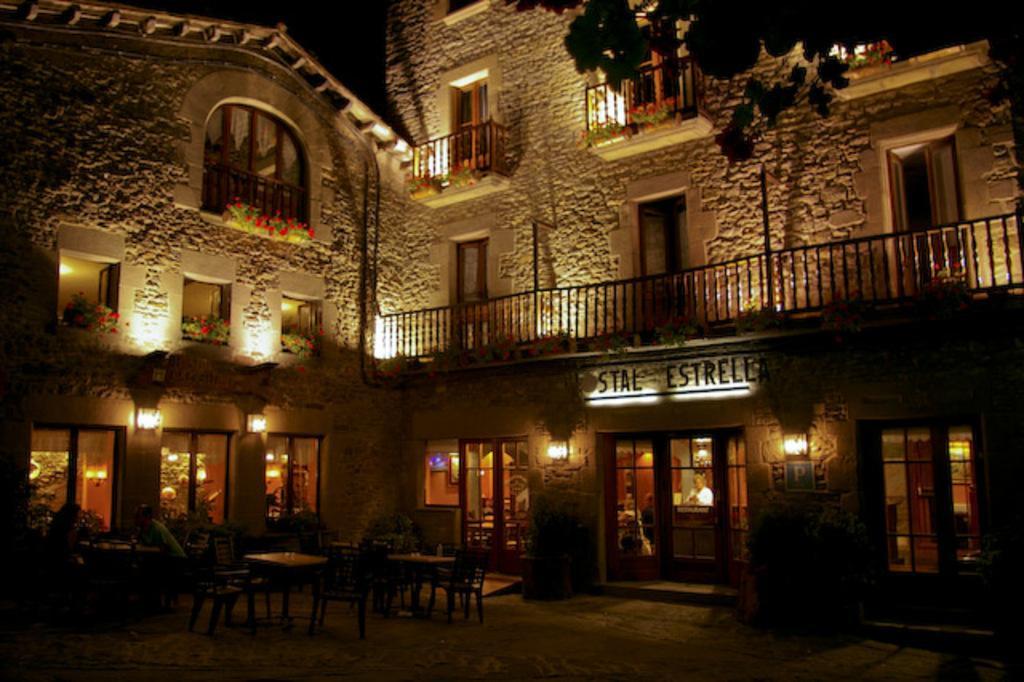In one or two sentences, can you explain what this image depicts? In this image we can see building, windows, plants, flowers, tree, lights, there is a person inside the building, there are tables, chairs. 